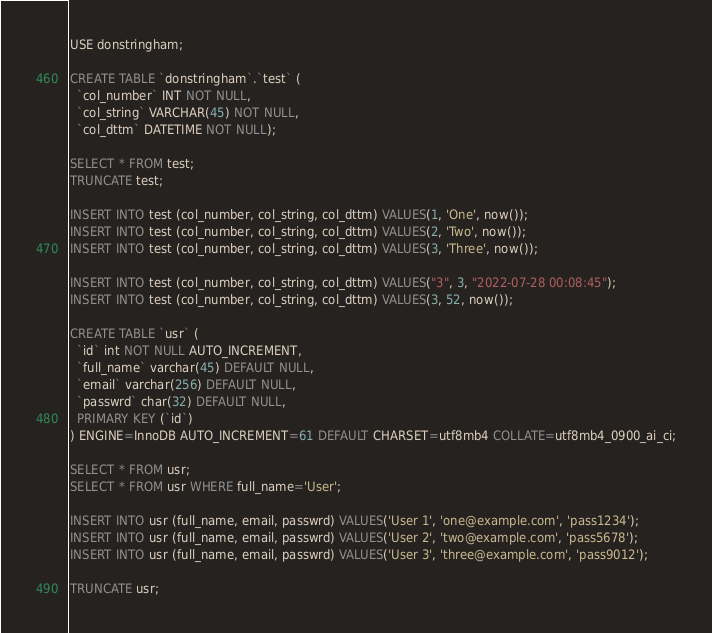Convert code to text. <code><loc_0><loc_0><loc_500><loc_500><_SQL_>USE donstringham;

CREATE TABLE `donstringham`.`test` (
  `col_number` INT NOT NULL,
  `col_string` VARCHAR(45) NOT NULL,
  `col_dttm` DATETIME NOT NULL);

SELECT * FROM test;
TRUNCATE test;

INSERT INTO test (col_number, col_string, col_dttm) VALUES(1, 'One', now());
INSERT INTO test (col_number, col_string, col_dttm) VALUES(2, 'Two', now());
INSERT INTO test (col_number, col_string, col_dttm) VALUES(3, 'Three', now());

INSERT INTO test (col_number, col_string, col_dttm) VALUES("3", 3, "2022-07-28 00:08:45");
INSERT INTO test (col_number, col_string, col_dttm) VALUES(3, 52, now());

CREATE TABLE `usr` (
  `id` int NOT NULL AUTO_INCREMENT,
  `full_name` varchar(45) DEFAULT NULL,
  `email` varchar(256) DEFAULT NULL,
  `passwrd` char(32) DEFAULT NULL,
  PRIMARY KEY (`id`)
) ENGINE=InnoDB AUTO_INCREMENT=61 DEFAULT CHARSET=utf8mb4 COLLATE=utf8mb4_0900_ai_ci;

SELECT * FROM usr;
SELECT * FROM usr WHERE full_name='User';

INSERT INTO usr (full_name, email, passwrd) VALUES('User 1', 'one@example.com', 'pass1234');
INSERT INTO usr (full_name, email, passwrd) VALUES('User 2', 'two@example.com', 'pass5678');
INSERT INTO usr (full_name, email, passwrd) VALUES('User 3', 'three@example.com', 'pass9012');

TRUNCATE usr;
</code> 